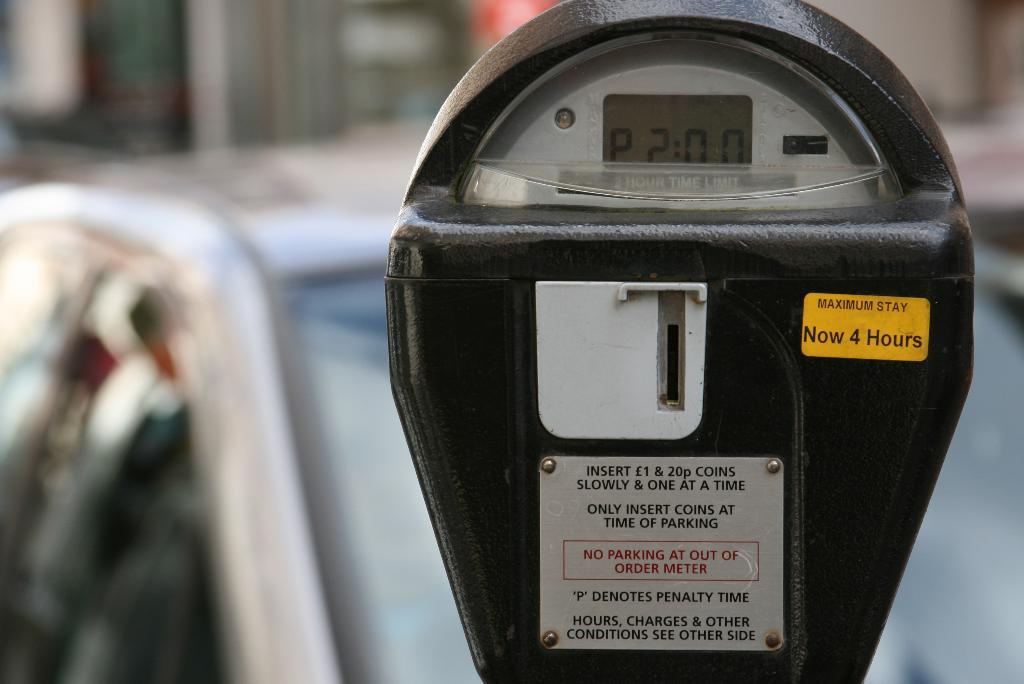Provide a one-sentence caption for the provided image. A parking meter displays two hours on the timer for a maximum of 4 hours. 